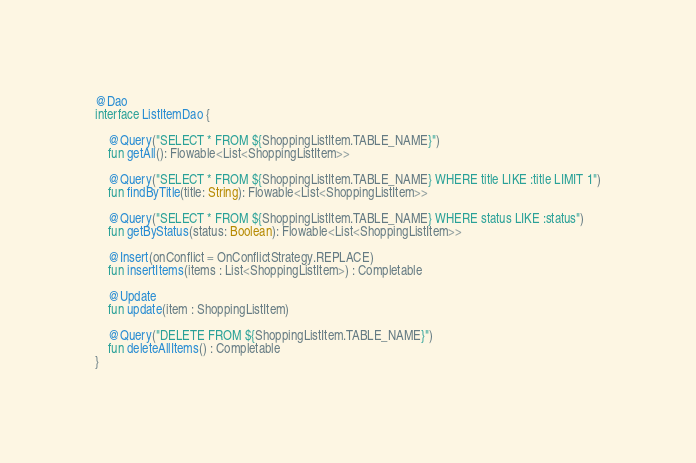Convert code to text. <code><loc_0><loc_0><loc_500><loc_500><_Kotlin_>
@Dao
interface ListItemDao {

    @Query("SELECT * FROM ${ShoppingListItem.TABLE_NAME}")
    fun getAll(): Flowable<List<ShoppingListItem>>

    @Query("SELECT * FROM ${ShoppingListItem.TABLE_NAME} WHERE title LIKE :title LIMIT 1")
    fun findByTitle(title: String): Flowable<List<ShoppingListItem>>

    @Query("SELECT * FROM ${ShoppingListItem.TABLE_NAME} WHERE status LIKE :status")
    fun getByStatus(status: Boolean): Flowable<List<ShoppingListItem>>

    @Insert(onConflict = OnConflictStrategy.REPLACE)
    fun insertItems(items : List<ShoppingListItem>) : Completable

    @Update
    fun update(item : ShoppingListItem)

    @Query("DELETE FROM ${ShoppingListItem.TABLE_NAME}")
    fun deleteAllItems() : Completable
}
</code> 